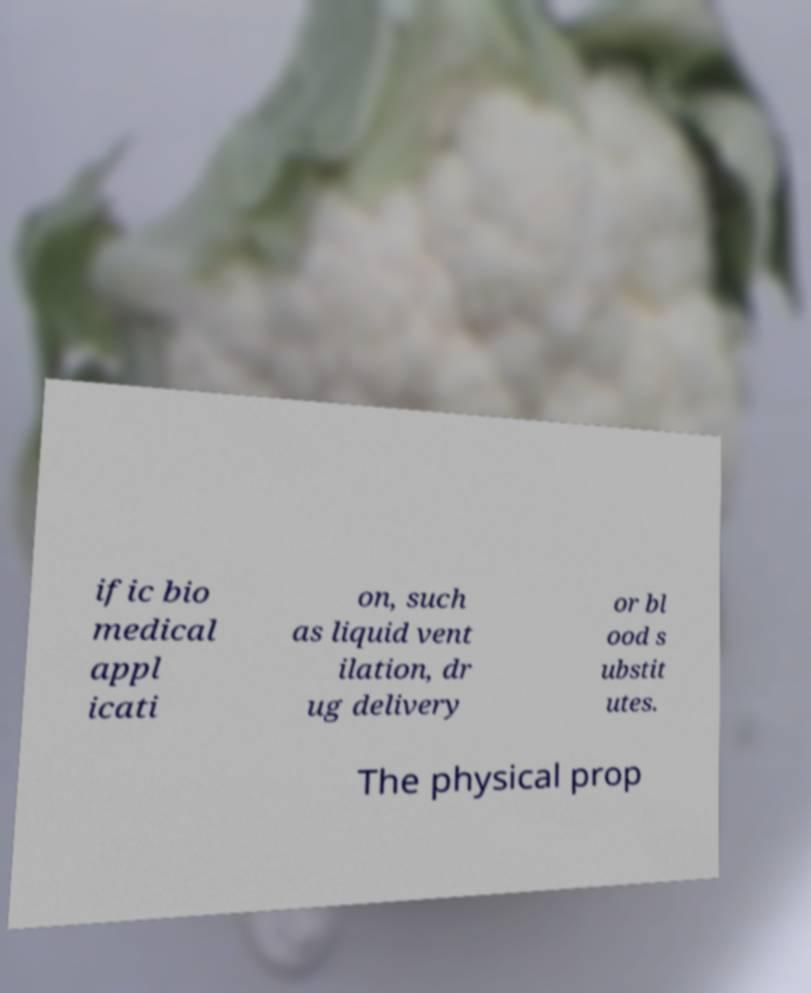What messages or text are displayed in this image? I need them in a readable, typed format. ific bio medical appl icati on, such as liquid vent ilation, dr ug delivery or bl ood s ubstit utes. The physical prop 